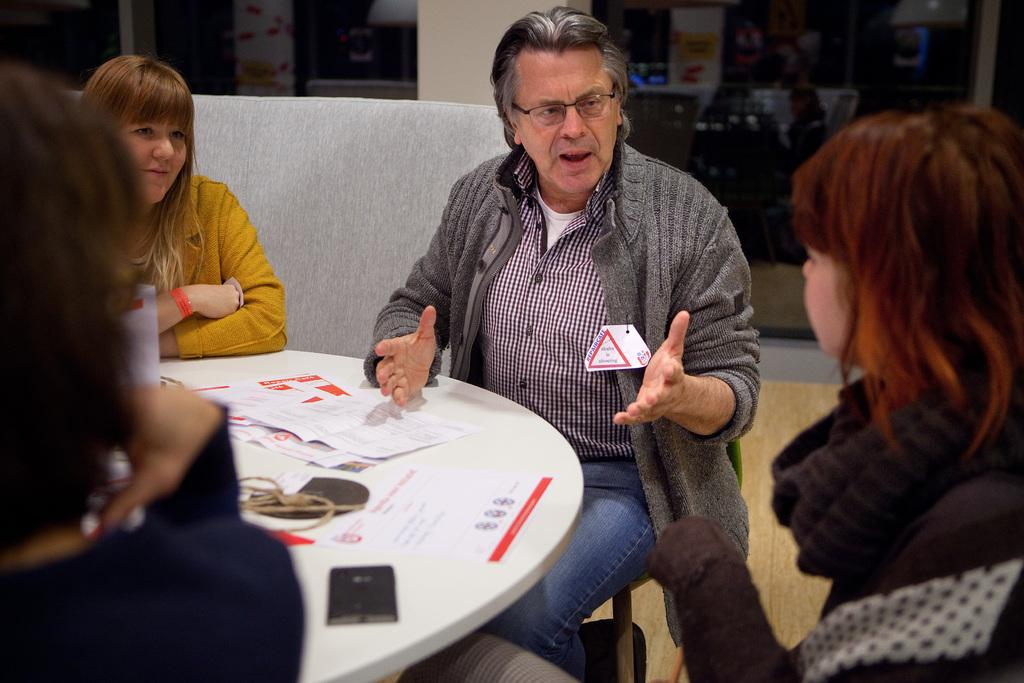How many people are sitting around the table in the image? There are four people sitting around the table in the image. What are the people sitting on? The people are sitting in chairs. What can be seen on the table besides the chairs? There are papers and a mobile on the table. What is visible in the background of the image? There is a sofa and a wall in the background. Where is the lamp located in the image? There is no lamp present in the image. Is there a hat on any of the people in the image? There is no hat visible on any of the people in the image. 